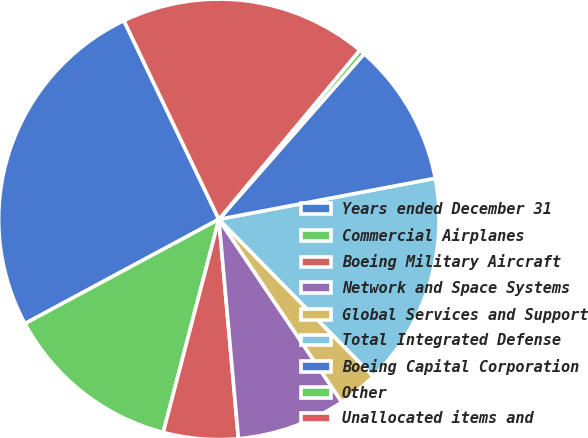<chart> <loc_0><loc_0><loc_500><loc_500><pie_chart><fcel>Years ended December 31<fcel>Commercial Airplanes<fcel>Boeing Military Aircraft<fcel>Network and Space Systems<fcel>Global Services and Support<fcel>Total Integrated Defense<fcel>Boeing Capital Corporation<fcel>Other<fcel>Unallocated items and<nl><fcel>25.75%<fcel>13.08%<fcel>5.48%<fcel>8.01%<fcel>2.94%<fcel>15.62%<fcel>10.55%<fcel>0.41%<fcel>18.15%<nl></chart> 